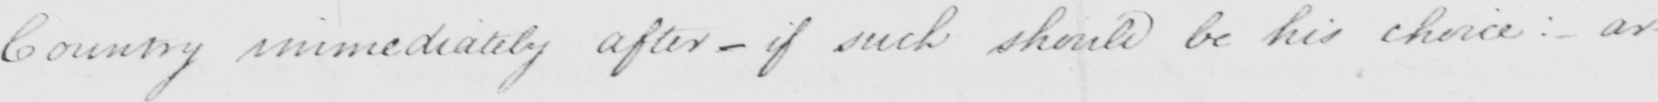Can you read and transcribe this handwriting? Country immediately after _ if such should be his choice: _ ar- 